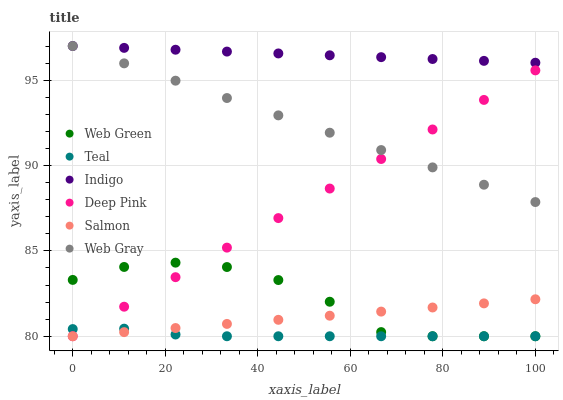Does Teal have the minimum area under the curve?
Answer yes or no. Yes. Does Indigo have the maximum area under the curve?
Answer yes or no. Yes. Does Salmon have the minimum area under the curve?
Answer yes or no. No. Does Salmon have the maximum area under the curve?
Answer yes or no. No. Is Web Gray the smoothest?
Answer yes or no. Yes. Is Web Green the roughest?
Answer yes or no. Yes. Is Indigo the smoothest?
Answer yes or no. No. Is Indigo the roughest?
Answer yes or no. No. Does Salmon have the lowest value?
Answer yes or no. Yes. Does Indigo have the lowest value?
Answer yes or no. No. Does Indigo have the highest value?
Answer yes or no. Yes. Does Salmon have the highest value?
Answer yes or no. No. Is Salmon less than Indigo?
Answer yes or no. Yes. Is Indigo greater than Deep Pink?
Answer yes or no. Yes. Does Deep Pink intersect Web Gray?
Answer yes or no. Yes. Is Deep Pink less than Web Gray?
Answer yes or no. No. Is Deep Pink greater than Web Gray?
Answer yes or no. No. Does Salmon intersect Indigo?
Answer yes or no. No. 